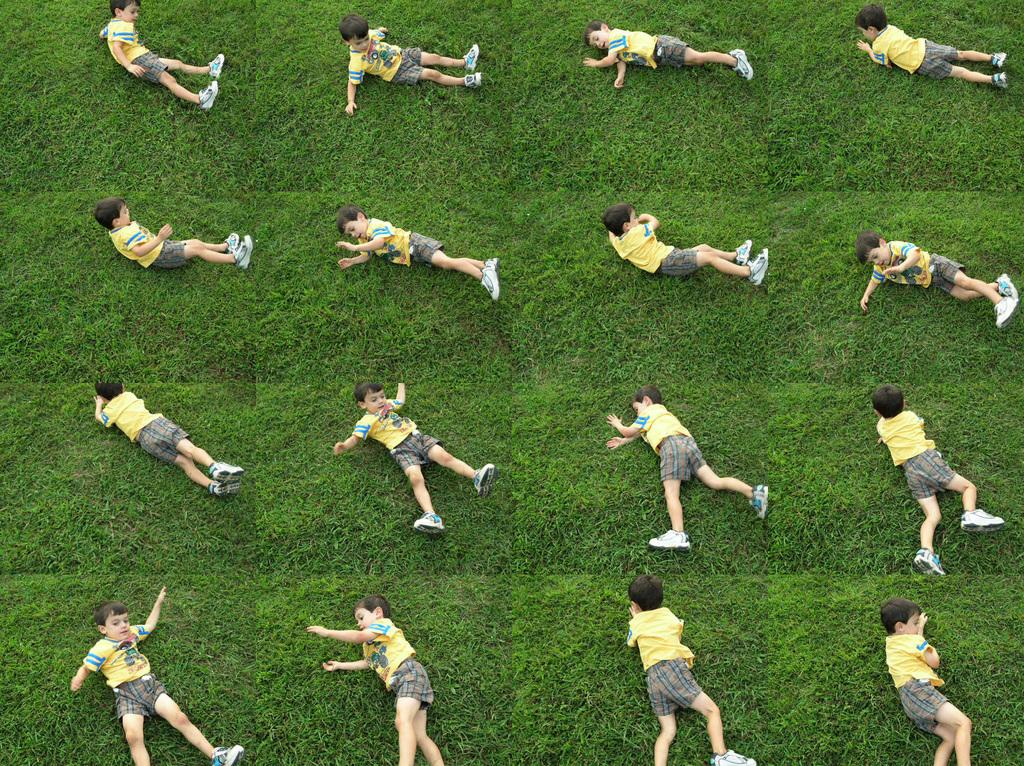What is the main subject of the image? The main subject of the image is a boy. What is the boy doing in the image? The boy is doing something on the grass. What type of top is the boy wearing in the image? There is no mention of a top in the provided facts, and therefore we cannot determine the type of top the boy is wearing. 